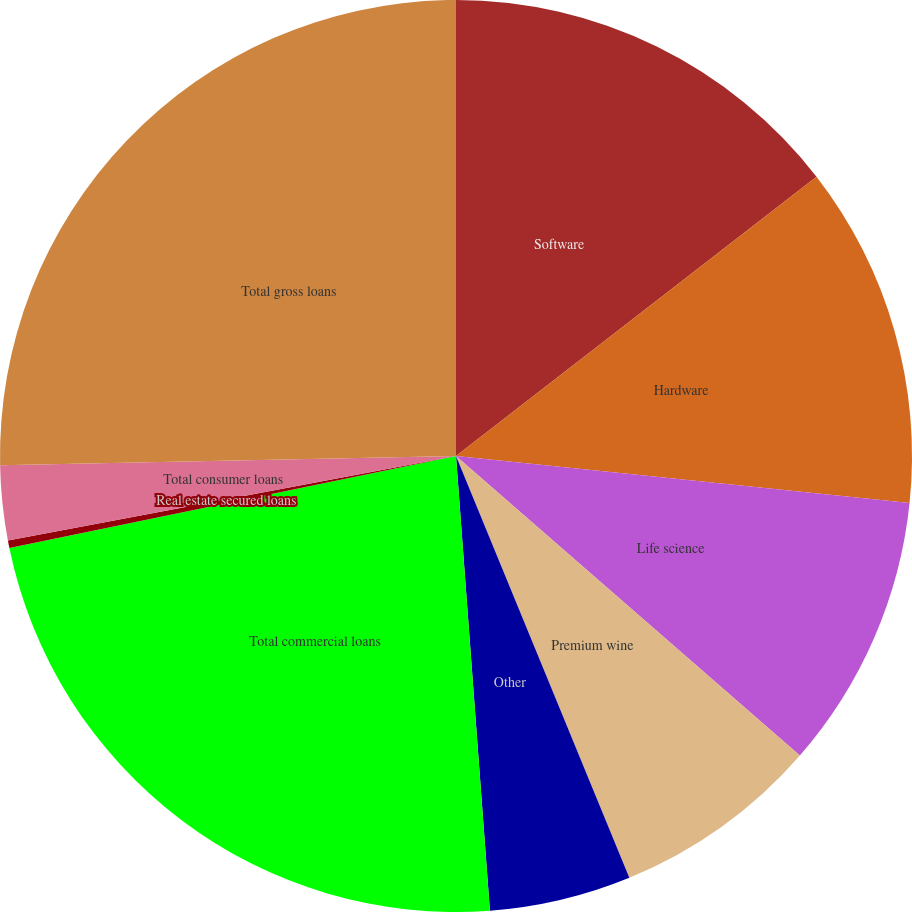Convert chart to OTSL. <chart><loc_0><loc_0><loc_500><loc_500><pie_chart><fcel>Software<fcel>Hardware<fcel>Life science<fcel>Premium wine<fcel>Other<fcel>Total commercial loans<fcel>Real estate secured loans<fcel>Total consumer loans<fcel>Total gross loans<nl><fcel>14.51%<fcel>12.13%<fcel>9.76%<fcel>7.39%<fcel>5.02%<fcel>22.95%<fcel>0.27%<fcel>2.64%<fcel>25.32%<nl></chart> 